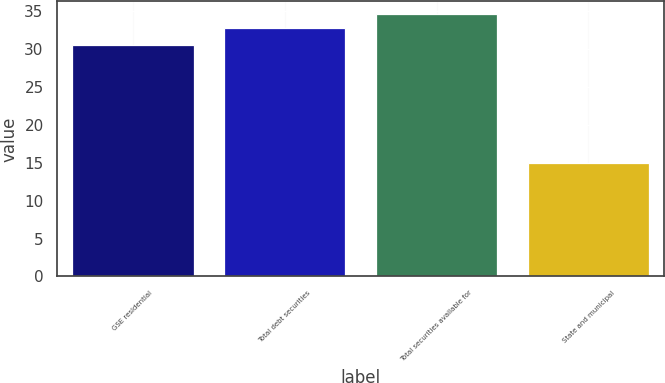Convert chart. <chart><loc_0><loc_0><loc_500><loc_500><bar_chart><fcel>GSE residential<fcel>Total debt securities<fcel>Total securities available for<fcel>State and municipal<nl><fcel>30.6<fcel>32.8<fcel>34.58<fcel>15<nl></chart> 